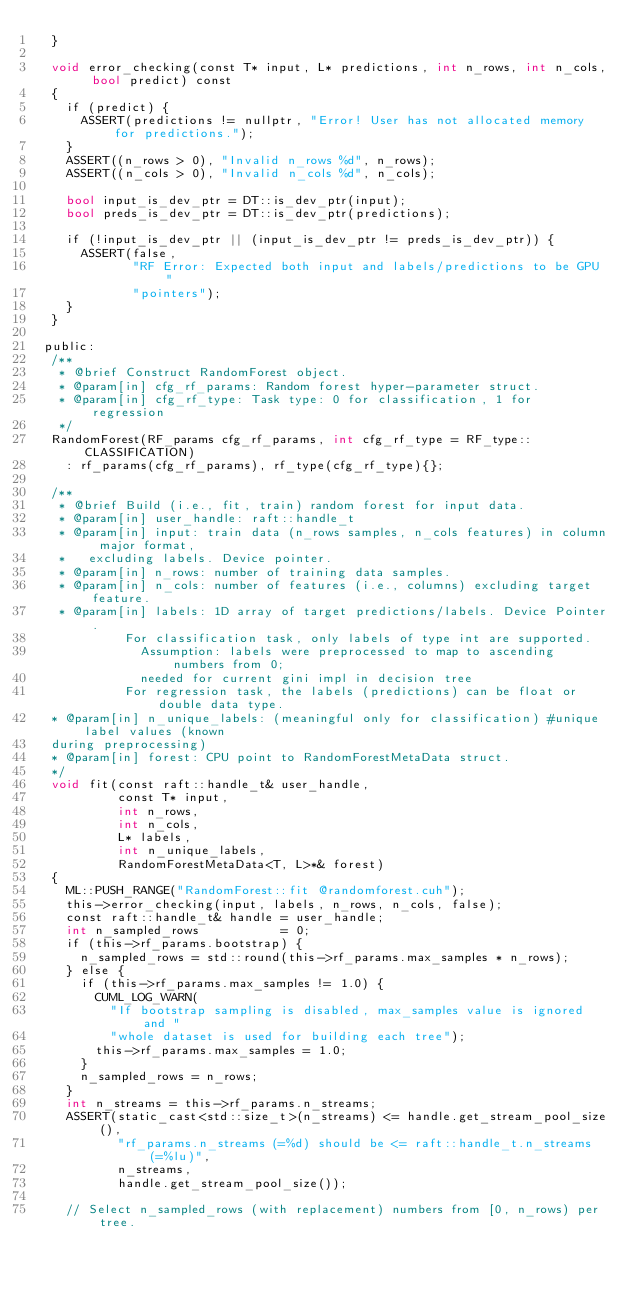<code> <loc_0><loc_0><loc_500><loc_500><_Cuda_>  }

  void error_checking(const T* input, L* predictions, int n_rows, int n_cols, bool predict) const
  {
    if (predict) {
      ASSERT(predictions != nullptr, "Error! User has not allocated memory for predictions.");
    }
    ASSERT((n_rows > 0), "Invalid n_rows %d", n_rows);
    ASSERT((n_cols > 0), "Invalid n_cols %d", n_cols);

    bool input_is_dev_ptr = DT::is_dev_ptr(input);
    bool preds_is_dev_ptr = DT::is_dev_ptr(predictions);

    if (!input_is_dev_ptr || (input_is_dev_ptr != preds_is_dev_ptr)) {
      ASSERT(false,
             "RF Error: Expected both input and labels/predictions to be GPU "
             "pointers");
    }
  }

 public:
  /**
   * @brief Construct RandomForest object.
   * @param[in] cfg_rf_params: Random forest hyper-parameter struct.
   * @param[in] cfg_rf_type: Task type: 0 for classification, 1 for regression
   */
  RandomForest(RF_params cfg_rf_params, int cfg_rf_type = RF_type::CLASSIFICATION)
    : rf_params(cfg_rf_params), rf_type(cfg_rf_type){};

  /**
   * @brief Build (i.e., fit, train) random forest for input data.
   * @param[in] user_handle: raft::handle_t
   * @param[in] input: train data (n_rows samples, n_cols features) in column major format,
   *   excluding labels. Device pointer.
   * @param[in] n_rows: number of training data samples.
   * @param[in] n_cols: number of features (i.e., columns) excluding target feature.
   * @param[in] labels: 1D array of target predictions/labels. Device Pointer.
            For classification task, only labels of type int are supported.
              Assumption: labels were preprocessed to map to ascending numbers from 0;
              needed for current gini impl in decision tree
            For regression task, the labels (predictions) can be float or double data type.
  * @param[in] n_unique_labels: (meaningful only for classification) #unique label values (known
  during preprocessing)
  * @param[in] forest: CPU point to RandomForestMetaData struct.
  */
  void fit(const raft::handle_t& user_handle,
           const T* input,
           int n_rows,
           int n_cols,
           L* labels,
           int n_unique_labels,
           RandomForestMetaData<T, L>*& forest)
  {
    ML::PUSH_RANGE("RandomForest::fit @randomforest.cuh");
    this->error_checking(input, labels, n_rows, n_cols, false);
    const raft::handle_t& handle = user_handle;
    int n_sampled_rows           = 0;
    if (this->rf_params.bootstrap) {
      n_sampled_rows = std::round(this->rf_params.max_samples * n_rows);
    } else {
      if (this->rf_params.max_samples != 1.0) {
        CUML_LOG_WARN(
          "If bootstrap sampling is disabled, max_samples value is ignored and "
          "whole dataset is used for building each tree");
        this->rf_params.max_samples = 1.0;
      }
      n_sampled_rows = n_rows;
    }
    int n_streams = this->rf_params.n_streams;
    ASSERT(static_cast<std::size_t>(n_streams) <= handle.get_stream_pool_size(),
           "rf_params.n_streams (=%d) should be <= raft::handle_t.n_streams (=%lu)",
           n_streams,
           handle.get_stream_pool_size());

    // Select n_sampled_rows (with replacement) numbers from [0, n_rows) per tree.</code> 